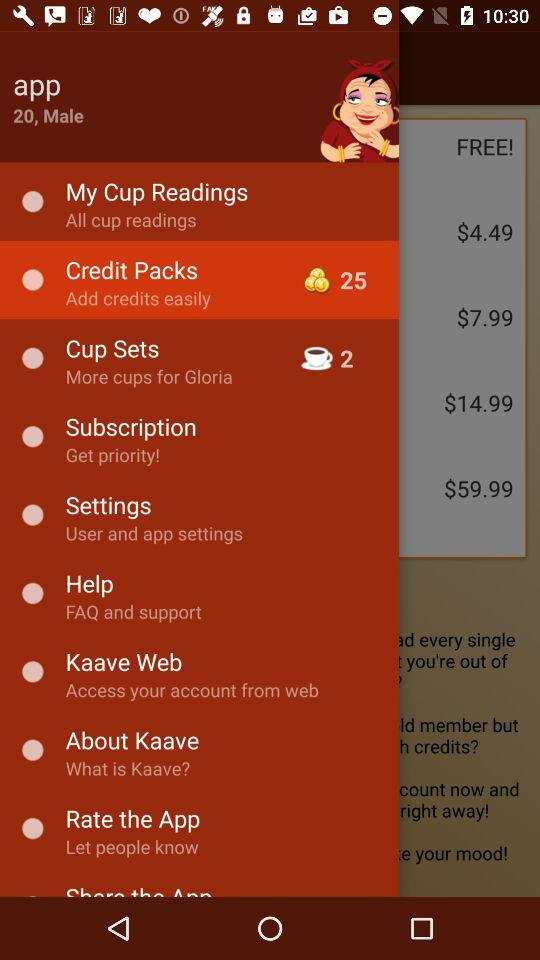What is the gender of the user? The gender of the user is male. 